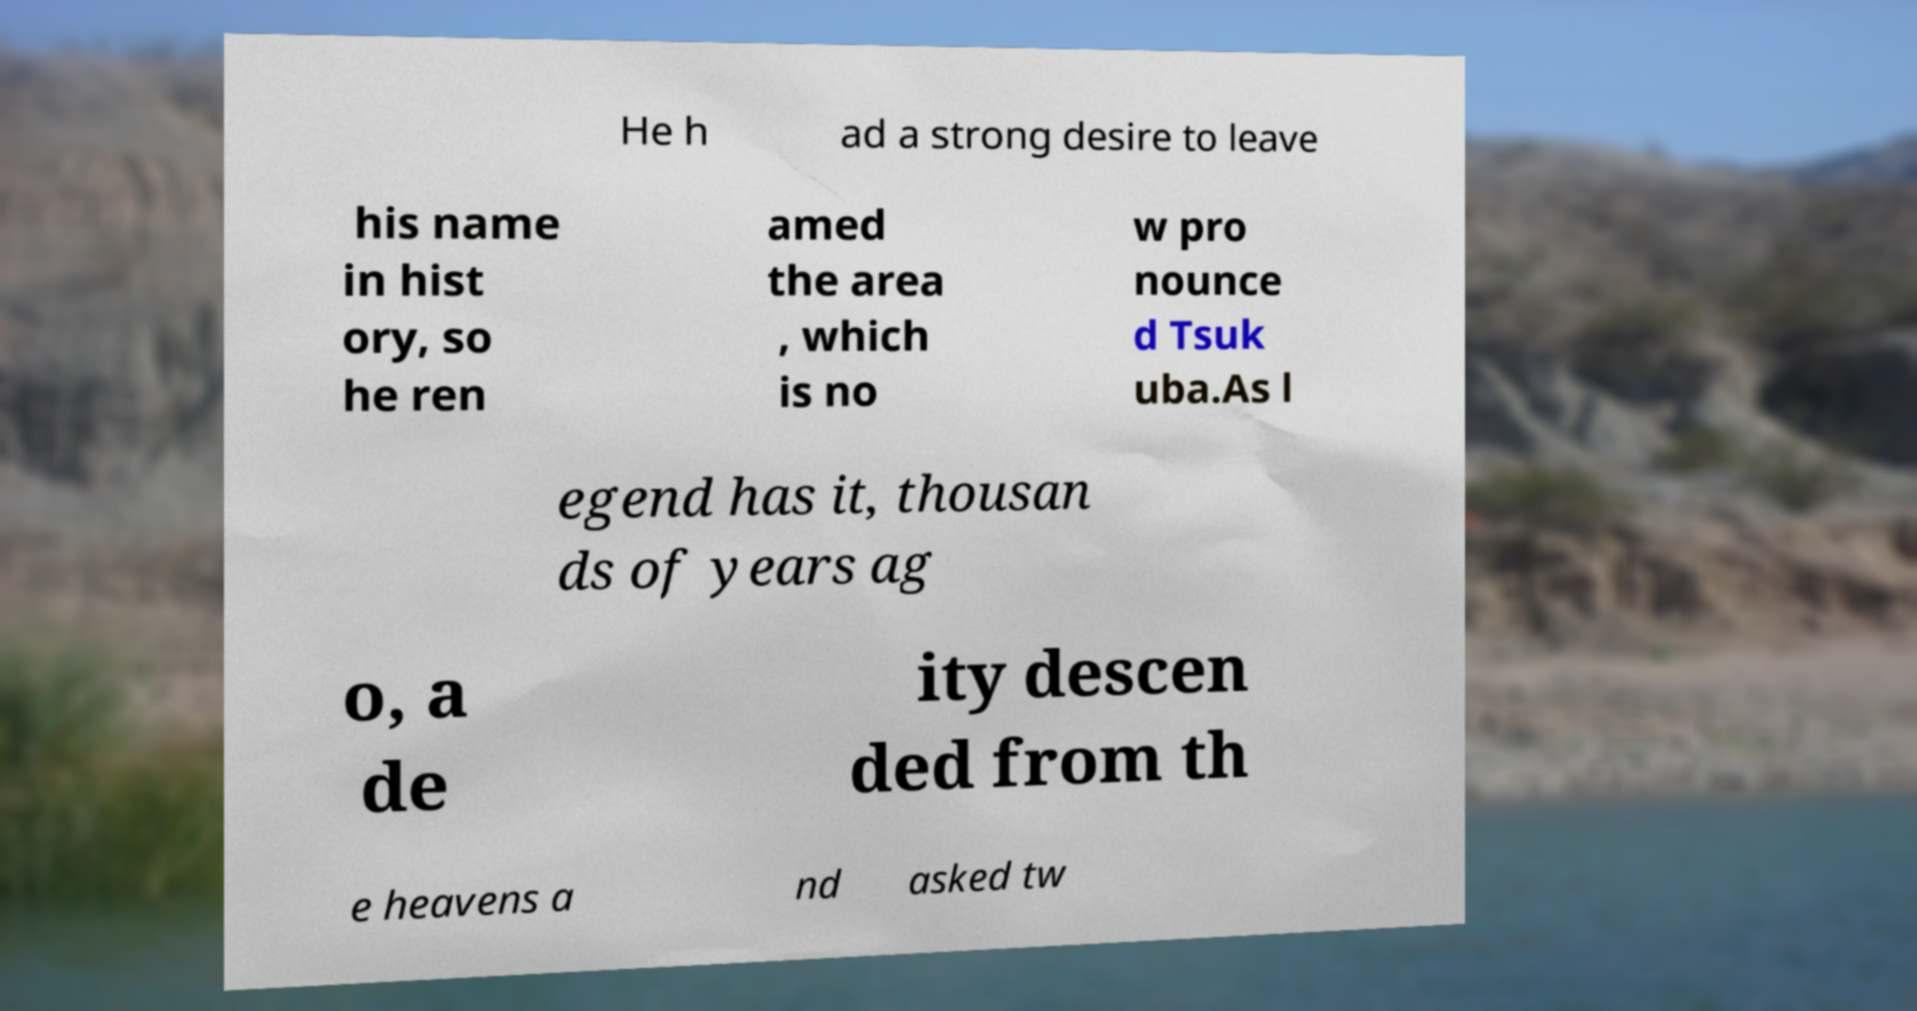What messages or text are displayed in this image? I need them in a readable, typed format. He h ad a strong desire to leave his name in hist ory, so he ren amed the area , which is no w pro nounce d Tsuk uba.As l egend has it, thousan ds of years ag o, a de ity descen ded from th e heavens a nd asked tw 